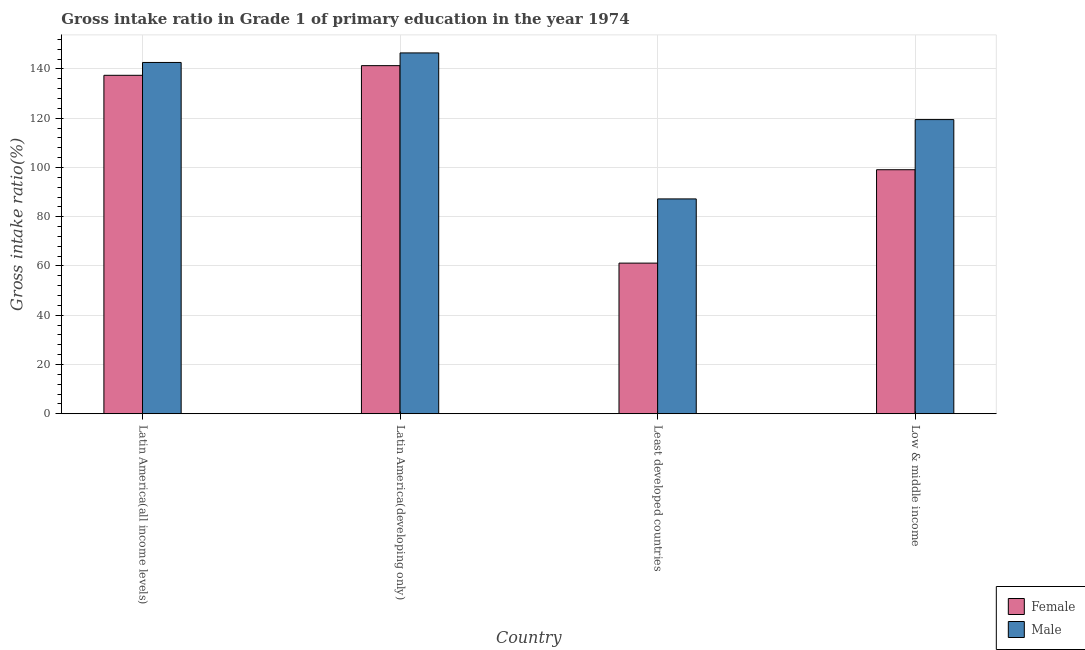Are the number of bars on each tick of the X-axis equal?
Provide a short and direct response. Yes. How many bars are there on the 4th tick from the left?
Keep it short and to the point. 2. What is the label of the 1st group of bars from the left?
Your response must be concise. Latin America(all income levels). What is the gross intake ratio(male) in Latin America(developing only)?
Keep it short and to the point. 146.52. Across all countries, what is the maximum gross intake ratio(female)?
Provide a short and direct response. 141.35. Across all countries, what is the minimum gross intake ratio(male)?
Your answer should be compact. 87.23. In which country was the gross intake ratio(male) maximum?
Give a very brief answer. Latin America(developing only). In which country was the gross intake ratio(male) minimum?
Your response must be concise. Least developed countries. What is the total gross intake ratio(male) in the graph?
Keep it short and to the point. 495.85. What is the difference between the gross intake ratio(female) in Latin America(developing only) and that in Least developed countries?
Offer a very short reply. 80.19. What is the difference between the gross intake ratio(female) in Latin America(all income levels) and the gross intake ratio(male) in Least developed countries?
Provide a short and direct response. 50.2. What is the average gross intake ratio(male) per country?
Your answer should be compact. 123.96. What is the difference between the gross intake ratio(female) and gross intake ratio(male) in Latin America(developing only)?
Keep it short and to the point. -5.17. In how many countries, is the gross intake ratio(female) greater than 104 %?
Give a very brief answer. 2. What is the ratio of the gross intake ratio(male) in Latin America(all income levels) to that in Low & middle income?
Keep it short and to the point. 1.19. Is the gross intake ratio(male) in Latin America(developing only) less than that in Low & middle income?
Keep it short and to the point. No. Is the difference between the gross intake ratio(female) in Latin America(developing only) and Low & middle income greater than the difference between the gross intake ratio(male) in Latin America(developing only) and Low & middle income?
Give a very brief answer. Yes. What is the difference between the highest and the second highest gross intake ratio(male)?
Offer a terse response. 3.88. What is the difference between the highest and the lowest gross intake ratio(male)?
Your answer should be very brief. 59.29. In how many countries, is the gross intake ratio(female) greater than the average gross intake ratio(female) taken over all countries?
Your answer should be very brief. 2. Are all the bars in the graph horizontal?
Your response must be concise. No. Does the graph contain any zero values?
Keep it short and to the point. No. Does the graph contain grids?
Keep it short and to the point. Yes. Where does the legend appear in the graph?
Your answer should be compact. Bottom right. What is the title of the graph?
Offer a terse response. Gross intake ratio in Grade 1 of primary education in the year 1974. Does "Merchandise exports" appear as one of the legend labels in the graph?
Ensure brevity in your answer.  No. What is the label or title of the X-axis?
Provide a succinct answer. Country. What is the label or title of the Y-axis?
Make the answer very short. Gross intake ratio(%). What is the Gross intake ratio(%) of Female in Latin America(all income levels)?
Offer a very short reply. 137.43. What is the Gross intake ratio(%) in Male in Latin America(all income levels)?
Provide a short and direct response. 142.64. What is the Gross intake ratio(%) of Female in Latin America(developing only)?
Offer a very short reply. 141.35. What is the Gross intake ratio(%) in Male in Latin America(developing only)?
Provide a short and direct response. 146.52. What is the Gross intake ratio(%) in Female in Least developed countries?
Offer a terse response. 61.16. What is the Gross intake ratio(%) in Male in Least developed countries?
Your response must be concise. 87.23. What is the Gross intake ratio(%) in Female in Low & middle income?
Your answer should be very brief. 99.09. What is the Gross intake ratio(%) in Male in Low & middle income?
Your answer should be compact. 119.45. Across all countries, what is the maximum Gross intake ratio(%) of Female?
Offer a very short reply. 141.35. Across all countries, what is the maximum Gross intake ratio(%) of Male?
Make the answer very short. 146.52. Across all countries, what is the minimum Gross intake ratio(%) in Female?
Your response must be concise. 61.16. Across all countries, what is the minimum Gross intake ratio(%) of Male?
Your response must be concise. 87.23. What is the total Gross intake ratio(%) in Female in the graph?
Make the answer very short. 439.03. What is the total Gross intake ratio(%) in Male in the graph?
Make the answer very short. 495.85. What is the difference between the Gross intake ratio(%) of Female in Latin America(all income levels) and that in Latin America(developing only)?
Offer a terse response. -3.92. What is the difference between the Gross intake ratio(%) in Male in Latin America(all income levels) and that in Latin America(developing only)?
Keep it short and to the point. -3.88. What is the difference between the Gross intake ratio(%) in Female in Latin America(all income levels) and that in Least developed countries?
Ensure brevity in your answer.  76.27. What is the difference between the Gross intake ratio(%) in Male in Latin America(all income levels) and that in Least developed countries?
Make the answer very short. 55.41. What is the difference between the Gross intake ratio(%) of Female in Latin America(all income levels) and that in Low & middle income?
Make the answer very short. 38.34. What is the difference between the Gross intake ratio(%) of Male in Latin America(all income levels) and that in Low & middle income?
Make the answer very short. 23.2. What is the difference between the Gross intake ratio(%) in Female in Latin America(developing only) and that in Least developed countries?
Ensure brevity in your answer.  80.19. What is the difference between the Gross intake ratio(%) of Male in Latin America(developing only) and that in Least developed countries?
Give a very brief answer. 59.29. What is the difference between the Gross intake ratio(%) in Female in Latin America(developing only) and that in Low & middle income?
Make the answer very short. 42.26. What is the difference between the Gross intake ratio(%) in Male in Latin America(developing only) and that in Low & middle income?
Give a very brief answer. 27.07. What is the difference between the Gross intake ratio(%) of Female in Least developed countries and that in Low & middle income?
Ensure brevity in your answer.  -37.93. What is the difference between the Gross intake ratio(%) in Male in Least developed countries and that in Low & middle income?
Keep it short and to the point. -32.21. What is the difference between the Gross intake ratio(%) in Female in Latin America(all income levels) and the Gross intake ratio(%) in Male in Latin America(developing only)?
Keep it short and to the point. -9.09. What is the difference between the Gross intake ratio(%) of Female in Latin America(all income levels) and the Gross intake ratio(%) of Male in Least developed countries?
Your answer should be compact. 50.2. What is the difference between the Gross intake ratio(%) in Female in Latin America(all income levels) and the Gross intake ratio(%) in Male in Low & middle income?
Offer a very short reply. 17.98. What is the difference between the Gross intake ratio(%) of Female in Latin America(developing only) and the Gross intake ratio(%) of Male in Least developed countries?
Make the answer very short. 54.12. What is the difference between the Gross intake ratio(%) in Female in Latin America(developing only) and the Gross intake ratio(%) in Male in Low & middle income?
Make the answer very short. 21.9. What is the difference between the Gross intake ratio(%) in Female in Least developed countries and the Gross intake ratio(%) in Male in Low & middle income?
Provide a succinct answer. -58.29. What is the average Gross intake ratio(%) in Female per country?
Keep it short and to the point. 109.76. What is the average Gross intake ratio(%) of Male per country?
Your answer should be compact. 123.96. What is the difference between the Gross intake ratio(%) of Female and Gross intake ratio(%) of Male in Latin America(all income levels)?
Your answer should be compact. -5.21. What is the difference between the Gross intake ratio(%) in Female and Gross intake ratio(%) in Male in Latin America(developing only)?
Give a very brief answer. -5.17. What is the difference between the Gross intake ratio(%) of Female and Gross intake ratio(%) of Male in Least developed countries?
Offer a terse response. -26.07. What is the difference between the Gross intake ratio(%) in Female and Gross intake ratio(%) in Male in Low & middle income?
Keep it short and to the point. -20.36. What is the ratio of the Gross intake ratio(%) of Female in Latin America(all income levels) to that in Latin America(developing only)?
Provide a short and direct response. 0.97. What is the ratio of the Gross intake ratio(%) in Male in Latin America(all income levels) to that in Latin America(developing only)?
Your answer should be compact. 0.97. What is the ratio of the Gross intake ratio(%) of Female in Latin America(all income levels) to that in Least developed countries?
Your response must be concise. 2.25. What is the ratio of the Gross intake ratio(%) of Male in Latin America(all income levels) to that in Least developed countries?
Ensure brevity in your answer.  1.64. What is the ratio of the Gross intake ratio(%) in Female in Latin America(all income levels) to that in Low & middle income?
Your answer should be very brief. 1.39. What is the ratio of the Gross intake ratio(%) in Male in Latin America(all income levels) to that in Low & middle income?
Provide a succinct answer. 1.19. What is the ratio of the Gross intake ratio(%) in Female in Latin America(developing only) to that in Least developed countries?
Your answer should be compact. 2.31. What is the ratio of the Gross intake ratio(%) of Male in Latin America(developing only) to that in Least developed countries?
Offer a very short reply. 1.68. What is the ratio of the Gross intake ratio(%) of Female in Latin America(developing only) to that in Low & middle income?
Offer a terse response. 1.43. What is the ratio of the Gross intake ratio(%) of Male in Latin America(developing only) to that in Low & middle income?
Offer a very short reply. 1.23. What is the ratio of the Gross intake ratio(%) of Female in Least developed countries to that in Low & middle income?
Provide a short and direct response. 0.62. What is the ratio of the Gross intake ratio(%) of Male in Least developed countries to that in Low & middle income?
Provide a short and direct response. 0.73. What is the difference between the highest and the second highest Gross intake ratio(%) of Female?
Your answer should be compact. 3.92. What is the difference between the highest and the second highest Gross intake ratio(%) in Male?
Offer a very short reply. 3.88. What is the difference between the highest and the lowest Gross intake ratio(%) in Female?
Give a very brief answer. 80.19. What is the difference between the highest and the lowest Gross intake ratio(%) in Male?
Make the answer very short. 59.29. 